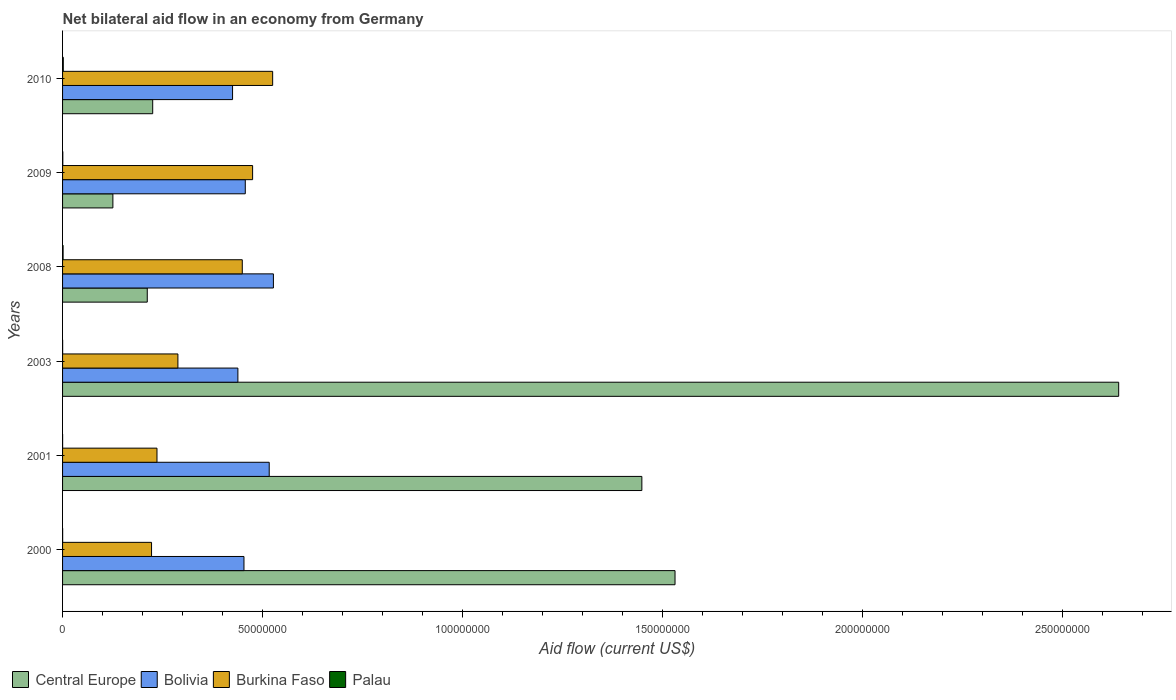Are the number of bars per tick equal to the number of legend labels?
Ensure brevity in your answer.  Yes. Are the number of bars on each tick of the Y-axis equal?
Ensure brevity in your answer.  Yes. How many bars are there on the 3rd tick from the top?
Keep it short and to the point. 4. How many bars are there on the 1st tick from the bottom?
Keep it short and to the point. 4. What is the label of the 4th group of bars from the top?
Your response must be concise. 2003. In how many cases, is the number of bars for a given year not equal to the number of legend labels?
Your answer should be compact. 0. What is the net bilateral aid flow in Bolivia in 2001?
Your answer should be very brief. 5.16e+07. Across all years, what is the minimum net bilateral aid flow in Central Europe?
Offer a terse response. 1.26e+07. In which year was the net bilateral aid flow in Bolivia maximum?
Give a very brief answer. 2008. In which year was the net bilateral aid flow in Burkina Faso minimum?
Your response must be concise. 2000. What is the total net bilateral aid flow in Burkina Faso in the graph?
Ensure brevity in your answer.  2.20e+08. What is the difference between the net bilateral aid flow in Bolivia in 2009 and the net bilateral aid flow in Central Europe in 2003?
Your answer should be very brief. -2.18e+08. What is the average net bilateral aid flow in Bolivia per year?
Ensure brevity in your answer.  4.69e+07. In the year 2003, what is the difference between the net bilateral aid flow in Bolivia and net bilateral aid flow in Palau?
Your answer should be compact. 4.38e+07. In how many years, is the net bilateral aid flow in Palau greater than 80000000 US$?
Keep it short and to the point. 0. What is the ratio of the net bilateral aid flow in Burkina Faso in 2000 to that in 2009?
Your response must be concise. 0.47. Is the difference between the net bilateral aid flow in Bolivia in 2001 and 2008 greater than the difference between the net bilateral aid flow in Palau in 2001 and 2008?
Provide a succinct answer. No. What is the difference between the highest and the second highest net bilateral aid flow in Central Europe?
Your answer should be very brief. 1.11e+08. In how many years, is the net bilateral aid flow in Burkina Faso greater than the average net bilateral aid flow in Burkina Faso taken over all years?
Make the answer very short. 3. Is it the case that in every year, the sum of the net bilateral aid flow in Burkina Faso and net bilateral aid flow in Palau is greater than the sum of net bilateral aid flow in Bolivia and net bilateral aid flow in Central Europe?
Keep it short and to the point. Yes. What does the 4th bar from the top in 2001 represents?
Make the answer very short. Central Europe. What does the 1st bar from the bottom in 2003 represents?
Keep it short and to the point. Central Europe. How many bars are there?
Your response must be concise. 24. How many years are there in the graph?
Ensure brevity in your answer.  6. Are the values on the major ticks of X-axis written in scientific E-notation?
Give a very brief answer. No. What is the title of the graph?
Keep it short and to the point. Net bilateral aid flow in an economy from Germany. What is the label or title of the Y-axis?
Ensure brevity in your answer.  Years. What is the Aid flow (current US$) in Central Europe in 2000?
Your response must be concise. 1.53e+08. What is the Aid flow (current US$) of Bolivia in 2000?
Keep it short and to the point. 4.53e+07. What is the Aid flow (current US$) in Burkina Faso in 2000?
Your response must be concise. 2.22e+07. What is the Aid flow (current US$) of Palau in 2000?
Provide a succinct answer. 2.00e+04. What is the Aid flow (current US$) of Central Europe in 2001?
Offer a terse response. 1.45e+08. What is the Aid flow (current US$) of Bolivia in 2001?
Make the answer very short. 5.16e+07. What is the Aid flow (current US$) of Burkina Faso in 2001?
Your answer should be very brief. 2.36e+07. What is the Aid flow (current US$) in Palau in 2001?
Give a very brief answer. 10000. What is the Aid flow (current US$) of Central Europe in 2003?
Give a very brief answer. 2.64e+08. What is the Aid flow (current US$) in Bolivia in 2003?
Make the answer very short. 4.38e+07. What is the Aid flow (current US$) of Burkina Faso in 2003?
Keep it short and to the point. 2.88e+07. What is the Aid flow (current US$) of Palau in 2003?
Your answer should be compact. 2.00e+04. What is the Aid flow (current US$) in Central Europe in 2008?
Your response must be concise. 2.12e+07. What is the Aid flow (current US$) in Bolivia in 2008?
Provide a succinct answer. 5.27e+07. What is the Aid flow (current US$) in Burkina Faso in 2008?
Make the answer very short. 4.49e+07. What is the Aid flow (current US$) in Central Europe in 2009?
Offer a very short reply. 1.26e+07. What is the Aid flow (current US$) in Bolivia in 2009?
Offer a terse response. 4.57e+07. What is the Aid flow (current US$) of Burkina Faso in 2009?
Give a very brief answer. 4.75e+07. What is the Aid flow (current US$) of Palau in 2009?
Ensure brevity in your answer.  6.00e+04. What is the Aid flow (current US$) in Central Europe in 2010?
Your answer should be compact. 2.25e+07. What is the Aid flow (current US$) in Bolivia in 2010?
Make the answer very short. 4.25e+07. What is the Aid flow (current US$) in Burkina Faso in 2010?
Make the answer very short. 5.25e+07. What is the Aid flow (current US$) of Palau in 2010?
Provide a succinct answer. 1.80e+05. Across all years, what is the maximum Aid flow (current US$) of Central Europe?
Provide a short and direct response. 2.64e+08. Across all years, what is the maximum Aid flow (current US$) of Bolivia?
Make the answer very short. 5.27e+07. Across all years, what is the maximum Aid flow (current US$) in Burkina Faso?
Offer a very short reply. 5.25e+07. Across all years, what is the minimum Aid flow (current US$) of Central Europe?
Your answer should be compact. 1.26e+07. Across all years, what is the minimum Aid flow (current US$) in Bolivia?
Offer a terse response. 4.25e+07. Across all years, what is the minimum Aid flow (current US$) in Burkina Faso?
Provide a short and direct response. 2.22e+07. What is the total Aid flow (current US$) in Central Europe in the graph?
Provide a succinct answer. 6.18e+08. What is the total Aid flow (current US$) in Bolivia in the graph?
Provide a short and direct response. 2.82e+08. What is the total Aid flow (current US$) of Burkina Faso in the graph?
Offer a very short reply. 2.20e+08. What is the total Aid flow (current US$) in Palau in the graph?
Your response must be concise. 4.20e+05. What is the difference between the Aid flow (current US$) in Central Europe in 2000 and that in 2001?
Your answer should be compact. 8.29e+06. What is the difference between the Aid flow (current US$) in Bolivia in 2000 and that in 2001?
Offer a terse response. -6.31e+06. What is the difference between the Aid flow (current US$) in Burkina Faso in 2000 and that in 2001?
Your answer should be very brief. -1.36e+06. What is the difference between the Aid flow (current US$) of Palau in 2000 and that in 2001?
Keep it short and to the point. 10000. What is the difference between the Aid flow (current US$) of Central Europe in 2000 and that in 2003?
Offer a very short reply. -1.11e+08. What is the difference between the Aid flow (current US$) of Bolivia in 2000 and that in 2003?
Provide a short and direct response. 1.52e+06. What is the difference between the Aid flow (current US$) in Burkina Faso in 2000 and that in 2003?
Your answer should be very brief. -6.59e+06. What is the difference between the Aid flow (current US$) in Central Europe in 2000 and that in 2008?
Offer a terse response. 1.32e+08. What is the difference between the Aid flow (current US$) of Bolivia in 2000 and that in 2008?
Your answer should be very brief. -7.36e+06. What is the difference between the Aid flow (current US$) of Burkina Faso in 2000 and that in 2008?
Your answer should be very brief. -2.27e+07. What is the difference between the Aid flow (current US$) of Palau in 2000 and that in 2008?
Offer a terse response. -1.10e+05. What is the difference between the Aid flow (current US$) in Central Europe in 2000 and that in 2009?
Offer a very short reply. 1.40e+08. What is the difference between the Aid flow (current US$) in Bolivia in 2000 and that in 2009?
Make the answer very short. -3.30e+05. What is the difference between the Aid flow (current US$) in Burkina Faso in 2000 and that in 2009?
Ensure brevity in your answer.  -2.53e+07. What is the difference between the Aid flow (current US$) in Central Europe in 2000 and that in 2010?
Make the answer very short. 1.31e+08. What is the difference between the Aid flow (current US$) in Bolivia in 2000 and that in 2010?
Ensure brevity in your answer.  2.85e+06. What is the difference between the Aid flow (current US$) of Burkina Faso in 2000 and that in 2010?
Provide a short and direct response. -3.03e+07. What is the difference between the Aid flow (current US$) of Central Europe in 2001 and that in 2003?
Keep it short and to the point. -1.19e+08. What is the difference between the Aid flow (current US$) in Bolivia in 2001 and that in 2003?
Your answer should be compact. 7.83e+06. What is the difference between the Aid flow (current US$) of Burkina Faso in 2001 and that in 2003?
Provide a short and direct response. -5.23e+06. What is the difference between the Aid flow (current US$) of Palau in 2001 and that in 2003?
Give a very brief answer. -10000. What is the difference between the Aid flow (current US$) in Central Europe in 2001 and that in 2008?
Your answer should be very brief. 1.24e+08. What is the difference between the Aid flow (current US$) in Bolivia in 2001 and that in 2008?
Make the answer very short. -1.05e+06. What is the difference between the Aid flow (current US$) in Burkina Faso in 2001 and that in 2008?
Make the answer very short. -2.13e+07. What is the difference between the Aid flow (current US$) of Palau in 2001 and that in 2008?
Your answer should be compact. -1.20e+05. What is the difference between the Aid flow (current US$) of Central Europe in 2001 and that in 2009?
Provide a short and direct response. 1.32e+08. What is the difference between the Aid flow (current US$) of Bolivia in 2001 and that in 2009?
Offer a terse response. 5.98e+06. What is the difference between the Aid flow (current US$) in Burkina Faso in 2001 and that in 2009?
Offer a terse response. -2.39e+07. What is the difference between the Aid flow (current US$) of Palau in 2001 and that in 2009?
Make the answer very short. -5.00e+04. What is the difference between the Aid flow (current US$) of Central Europe in 2001 and that in 2010?
Offer a very short reply. 1.22e+08. What is the difference between the Aid flow (current US$) of Bolivia in 2001 and that in 2010?
Give a very brief answer. 9.16e+06. What is the difference between the Aid flow (current US$) in Burkina Faso in 2001 and that in 2010?
Your answer should be very brief. -2.89e+07. What is the difference between the Aid flow (current US$) of Palau in 2001 and that in 2010?
Ensure brevity in your answer.  -1.70e+05. What is the difference between the Aid flow (current US$) of Central Europe in 2003 and that in 2008?
Make the answer very short. 2.43e+08. What is the difference between the Aid flow (current US$) of Bolivia in 2003 and that in 2008?
Keep it short and to the point. -8.88e+06. What is the difference between the Aid flow (current US$) in Burkina Faso in 2003 and that in 2008?
Offer a very short reply. -1.61e+07. What is the difference between the Aid flow (current US$) of Palau in 2003 and that in 2008?
Offer a terse response. -1.10e+05. What is the difference between the Aid flow (current US$) in Central Europe in 2003 and that in 2009?
Your answer should be compact. 2.51e+08. What is the difference between the Aid flow (current US$) of Bolivia in 2003 and that in 2009?
Your answer should be compact. -1.85e+06. What is the difference between the Aid flow (current US$) of Burkina Faso in 2003 and that in 2009?
Offer a terse response. -1.87e+07. What is the difference between the Aid flow (current US$) of Palau in 2003 and that in 2009?
Ensure brevity in your answer.  -4.00e+04. What is the difference between the Aid flow (current US$) of Central Europe in 2003 and that in 2010?
Your answer should be compact. 2.41e+08. What is the difference between the Aid flow (current US$) of Bolivia in 2003 and that in 2010?
Your response must be concise. 1.33e+06. What is the difference between the Aid flow (current US$) of Burkina Faso in 2003 and that in 2010?
Provide a short and direct response. -2.37e+07. What is the difference between the Aid flow (current US$) of Central Europe in 2008 and that in 2009?
Offer a very short reply. 8.59e+06. What is the difference between the Aid flow (current US$) of Bolivia in 2008 and that in 2009?
Provide a succinct answer. 7.03e+06. What is the difference between the Aid flow (current US$) of Burkina Faso in 2008 and that in 2009?
Provide a short and direct response. -2.58e+06. What is the difference between the Aid flow (current US$) in Central Europe in 2008 and that in 2010?
Keep it short and to the point. -1.36e+06. What is the difference between the Aid flow (current US$) of Bolivia in 2008 and that in 2010?
Your answer should be compact. 1.02e+07. What is the difference between the Aid flow (current US$) of Burkina Faso in 2008 and that in 2010?
Offer a very short reply. -7.59e+06. What is the difference between the Aid flow (current US$) of Central Europe in 2009 and that in 2010?
Make the answer very short. -9.95e+06. What is the difference between the Aid flow (current US$) of Bolivia in 2009 and that in 2010?
Offer a terse response. 3.18e+06. What is the difference between the Aid flow (current US$) in Burkina Faso in 2009 and that in 2010?
Ensure brevity in your answer.  -5.01e+06. What is the difference between the Aid flow (current US$) in Central Europe in 2000 and the Aid flow (current US$) in Bolivia in 2001?
Keep it short and to the point. 1.01e+08. What is the difference between the Aid flow (current US$) in Central Europe in 2000 and the Aid flow (current US$) in Burkina Faso in 2001?
Your answer should be very brief. 1.29e+08. What is the difference between the Aid flow (current US$) in Central Europe in 2000 and the Aid flow (current US$) in Palau in 2001?
Keep it short and to the point. 1.53e+08. What is the difference between the Aid flow (current US$) of Bolivia in 2000 and the Aid flow (current US$) of Burkina Faso in 2001?
Provide a short and direct response. 2.17e+07. What is the difference between the Aid flow (current US$) in Bolivia in 2000 and the Aid flow (current US$) in Palau in 2001?
Your answer should be very brief. 4.53e+07. What is the difference between the Aid flow (current US$) in Burkina Faso in 2000 and the Aid flow (current US$) in Palau in 2001?
Keep it short and to the point. 2.22e+07. What is the difference between the Aid flow (current US$) in Central Europe in 2000 and the Aid flow (current US$) in Bolivia in 2003?
Offer a very short reply. 1.09e+08. What is the difference between the Aid flow (current US$) in Central Europe in 2000 and the Aid flow (current US$) in Burkina Faso in 2003?
Your response must be concise. 1.24e+08. What is the difference between the Aid flow (current US$) in Central Europe in 2000 and the Aid flow (current US$) in Palau in 2003?
Keep it short and to the point. 1.53e+08. What is the difference between the Aid flow (current US$) of Bolivia in 2000 and the Aid flow (current US$) of Burkina Faso in 2003?
Your answer should be compact. 1.65e+07. What is the difference between the Aid flow (current US$) of Bolivia in 2000 and the Aid flow (current US$) of Palau in 2003?
Make the answer very short. 4.53e+07. What is the difference between the Aid flow (current US$) in Burkina Faso in 2000 and the Aid flow (current US$) in Palau in 2003?
Give a very brief answer. 2.22e+07. What is the difference between the Aid flow (current US$) in Central Europe in 2000 and the Aid flow (current US$) in Bolivia in 2008?
Give a very brief answer. 1.00e+08. What is the difference between the Aid flow (current US$) of Central Europe in 2000 and the Aid flow (current US$) of Burkina Faso in 2008?
Your answer should be very brief. 1.08e+08. What is the difference between the Aid flow (current US$) of Central Europe in 2000 and the Aid flow (current US$) of Palau in 2008?
Give a very brief answer. 1.53e+08. What is the difference between the Aid flow (current US$) of Bolivia in 2000 and the Aid flow (current US$) of Burkina Faso in 2008?
Offer a terse response. 4.20e+05. What is the difference between the Aid flow (current US$) of Bolivia in 2000 and the Aid flow (current US$) of Palau in 2008?
Provide a short and direct response. 4.52e+07. What is the difference between the Aid flow (current US$) in Burkina Faso in 2000 and the Aid flow (current US$) in Palau in 2008?
Provide a succinct answer. 2.21e+07. What is the difference between the Aid flow (current US$) in Central Europe in 2000 and the Aid flow (current US$) in Bolivia in 2009?
Make the answer very short. 1.07e+08. What is the difference between the Aid flow (current US$) in Central Europe in 2000 and the Aid flow (current US$) in Burkina Faso in 2009?
Give a very brief answer. 1.06e+08. What is the difference between the Aid flow (current US$) in Central Europe in 2000 and the Aid flow (current US$) in Palau in 2009?
Your answer should be compact. 1.53e+08. What is the difference between the Aid flow (current US$) of Bolivia in 2000 and the Aid flow (current US$) of Burkina Faso in 2009?
Keep it short and to the point. -2.16e+06. What is the difference between the Aid flow (current US$) of Bolivia in 2000 and the Aid flow (current US$) of Palau in 2009?
Make the answer very short. 4.53e+07. What is the difference between the Aid flow (current US$) in Burkina Faso in 2000 and the Aid flow (current US$) in Palau in 2009?
Ensure brevity in your answer.  2.22e+07. What is the difference between the Aid flow (current US$) in Central Europe in 2000 and the Aid flow (current US$) in Bolivia in 2010?
Offer a terse response. 1.11e+08. What is the difference between the Aid flow (current US$) of Central Europe in 2000 and the Aid flow (current US$) of Burkina Faso in 2010?
Provide a succinct answer. 1.01e+08. What is the difference between the Aid flow (current US$) in Central Europe in 2000 and the Aid flow (current US$) in Palau in 2010?
Your answer should be compact. 1.53e+08. What is the difference between the Aid flow (current US$) of Bolivia in 2000 and the Aid flow (current US$) of Burkina Faso in 2010?
Offer a very short reply. -7.17e+06. What is the difference between the Aid flow (current US$) of Bolivia in 2000 and the Aid flow (current US$) of Palau in 2010?
Offer a terse response. 4.52e+07. What is the difference between the Aid flow (current US$) of Burkina Faso in 2000 and the Aid flow (current US$) of Palau in 2010?
Your answer should be very brief. 2.21e+07. What is the difference between the Aid flow (current US$) of Central Europe in 2001 and the Aid flow (current US$) of Bolivia in 2003?
Give a very brief answer. 1.01e+08. What is the difference between the Aid flow (current US$) of Central Europe in 2001 and the Aid flow (current US$) of Burkina Faso in 2003?
Provide a succinct answer. 1.16e+08. What is the difference between the Aid flow (current US$) in Central Europe in 2001 and the Aid flow (current US$) in Palau in 2003?
Offer a terse response. 1.45e+08. What is the difference between the Aid flow (current US$) in Bolivia in 2001 and the Aid flow (current US$) in Burkina Faso in 2003?
Ensure brevity in your answer.  2.28e+07. What is the difference between the Aid flow (current US$) in Bolivia in 2001 and the Aid flow (current US$) in Palau in 2003?
Your answer should be very brief. 5.16e+07. What is the difference between the Aid flow (current US$) of Burkina Faso in 2001 and the Aid flow (current US$) of Palau in 2003?
Provide a short and direct response. 2.36e+07. What is the difference between the Aid flow (current US$) of Central Europe in 2001 and the Aid flow (current US$) of Bolivia in 2008?
Offer a very short reply. 9.21e+07. What is the difference between the Aid flow (current US$) of Central Europe in 2001 and the Aid flow (current US$) of Burkina Faso in 2008?
Your answer should be very brief. 9.99e+07. What is the difference between the Aid flow (current US$) of Central Europe in 2001 and the Aid flow (current US$) of Palau in 2008?
Offer a very short reply. 1.45e+08. What is the difference between the Aid flow (current US$) in Bolivia in 2001 and the Aid flow (current US$) in Burkina Faso in 2008?
Keep it short and to the point. 6.73e+06. What is the difference between the Aid flow (current US$) of Bolivia in 2001 and the Aid flow (current US$) of Palau in 2008?
Keep it short and to the point. 5.15e+07. What is the difference between the Aid flow (current US$) in Burkina Faso in 2001 and the Aid flow (current US$) in Palau in 2008?
Make the answer very short. 2.35e+07. What is the difference between the Aid flow (current US$) in Central Europe in 2001 and the Aid flow (current US$) in Bolivia in 2009?
Offer a terse response. 9.91e+07. What is the difference between the Aid flow (current US$) in Central Europe in 2001 and the Aid flow (current US$) in Burkina Faso in 2009?
Your answer should be very brief. 9.73e+07. What is the difference between the Aid flow (current US$) of Central Europe in 2001 and the Aid flow (current US$) of Palau in 2009?
Offer a very short reply. 1.45e+08. What is the difference between the Aid flow (current US$) in Bolivia in 2001 and the Aid flow (current US$) in Burkina Faso in 2009?
Keep it short and to the point. 4.15e+06. What is the difference between the Aid flow (current US$) in Bolivia in 2001 and the Aid flow (current US$) in Palau in 2009?
Ensure brevity in your answer.  5.16e+07. What is the difference between the Aid flow (current US$) of Burkina Faso in 2001 and the Aid flow (current US$) of Palau in 2009?
Your response must be concise. 2.35e+07. What is the difference between the Aid flow (current US$) of Central Europe in 2001 and the Aid flow (current US$) of Bolivia in 2010?
Your answer should be very brief. 1.02e+08. What is the difference between the Aid flow (current US$) in Central Europe in 2001 and the Aid flow (current US$) in Burkina Faso in 2010?
Your answer should be very brief. 9.23e+07. What is the difference between the Aid flow (current US$) in Central Europe in 2001 and the Aid flow (current US$) in Palau in 2010?
Ensure brevity in your answer.  1.45e+08. What is the difference between the Aid flow (current US$) in Bolivia in 2001 and the Aid flow (current US$) in Burkina Faso in 2010?
Your response must be concise. -8.60e+05. What is the difference between the Aid flow (current US$) in Bolivia in 2001 and the Aid flow (current US$) in Palau in 2010?
Give a very brief answer. 5.15e+07. What is the difference between the Aid flow (current US$) in Burkina Faso in 2001 and the Aid flow (current US$) in Palau in 2010?
Your response must be concise. 2.34e+07. What is the difference between the Aid flow (current US$) in Central Europe in 2003 and the Aid flow (current US$) in Bolivia in 2008?
Make the answer very short. 2.11e+08. What is the difference between the Aid flow (current US$) of Central Europe in 2003 and the Aid flow (current US$) of Burkina Faso in 2008?
Provide a short and direct response. 2.19e+08. What is the difference between the Aid flow (current US$) in Central Europe in 2003 and the Aid flow (current US$) in Palau in 2008?
Provide a short and direct response. 2.64e+08. What is the difference between the Aid flow (current US$) of Bolivia in 2003 and the Aid flow (current US$) of Burkina Faso in 2008?
Your answer should be very brief. -1.10e+06. What is the difference between the Aid flow (current US$) of Bolivia in 2003 and the Aid flow (current US$) of Palau in 2008?
Your response must be concise. 4.37e+07. What is the difference between the Aid flow (current US$) in Burkina Faso in 2003 and the Aid flow (current US$) in Palau in 2008?
Ensure brevity in your answer.  2.87e+07. What is the difference between the Aid flow (current US$) in Central Europe in 2003 and the Aid flow (current US$) in Bolivia in 2009?
Your answer should be very brief. 2.18e+08. What is the difference between the Aid flow (current US$) of Central Europe in 2003 and the Aid flow (current US$) of Burkina Faso in 2009?
Keep it short and to the point. 2.16e+08. What is the difference between the Aid flow (current US$) in Central Europe in 2003 and the Aid flow (current US$) in Palau in 2009?
Your answer should be compact. 2.64e+08. What is the difference between the Aid flow (current US$) in Bolivia in 2003 and the Aid flow (current US$) in Burkina Faso in 2009?
Your response must be concise. -3.68e+06. What is the difference between the Aid flow (current US$) in Bolivia in 2003 and the Aid flow (current US$) in Palau in 2009?
Your response must be concise. 4.38e+07. What is the difference between the Aid flow (current US$) of Burkina Faso in 2003 and the Aid flow (current US$) of Palau in 2009?
Your answer should be compact. 2.88e+07. What is the difference between the Aid flow (current US$) in Central Europe in 2003 and the Aid flow (current US$) in Bolivia in 2010?
Ensure brevity in your answer.  2.21e+08. What is the difference between the Aid flow (current US$) of Central Europe in 2003 and the Aid flow (current US$) of Burkina Faso in 2010?
Your answer should be very brief. 2.11e+08. What is the difference between the Aid flow (current US$) of Central Europe in 2003 and the Aid flow (current US$) of Palau in 2010?
Your answer should be very brief. 2.64e+08. What is the difference between the Aid flow (current US$) in Bolivia in 2003 and the Aid flow (current US$) in Burkina Faso in 2010?
Provide a short and direct response. -8.69e+06. What is the difference between the Aid flow (current US$) of Bolivia in 2003 and the Aid flow (current US$) of Palau in 2010?
Provide a short and direct response. 4.36e+07. What is the difference between the Aid flow (current US$) in Burkina Faso in 2003 and the Aid flow (current US$) in Palau in 2010?
Keep it short and to the point. 2.86e+07. What is the difference between the Aid flow (current US$) in Central Europe in 2008 and the Aid flow (current US$) in Bolivia in 2009?
Your answer should be very brief. -2.45e+07. What is the difference between the Aid flow (current US$) in Central Europe in 2008 and the Aid flow (current US$) in Burkina Faso in 2009?
Offer a very short reply. -2.63e+07. What is the difference between the Aid flow (current US$) in Central Europe in 2008 and the Aid flow (current US$) in Palau in 2009?
Offer a terse response. 2.11e+07. What is the difference between the Aid flow (current US$) in Bolivia in 2008 and the Aid flow (current US$) in Burkina Faso in 2009?
Your answer should be very brief. 5.20e+06. What is the difference between the Aid flow (current US$) in Bolivia in 2008 and the Aid flow (current US$) in Palau in 2009?
Your answer should be very brief. 5.26e+07. What is the difference between the Aid flow (current US$) of Burkina Faso in 2008 and the Aid flow (current US$) of Palau in 2009?
Provide a succinct answer. 4.49e+07. What is the difference between the Aid flow (current US$) of Central Europe in 2008 and the Aid flow (current US$) of Bolivia in 2010?
Your response must be concise. -2.13e+07. What is the difference between the Aid flow (current US$) in Central Europe in 2008 and the Aid flow (current US$) in Burkina Faso in 2010?
Provide a short and direct response. -3.13e+07. What is the difference between the Aid flow (current US$) in Central Europe in 2008 and the Aid flow (current US$) in Palau in 2010?
Offer a terse response. 2.10e+07. What is the difference between the Aid flow (current US$) in Bolivia in 2008 and the Aid flow (current US$) in Palau in 2010?
Provide a short and direct response. 5.25e+07. What is the difference between the Aid flow (current US$) in Burkina Faso in 2008 and the Aid flow (current US$) in Palau in 2010?
Ensure brevity in your answer.  4.47e+07. What is the difference between the Aid flow (current US$) in Central Europe in 2009 and the Aid flow (current US$) in Bolivia in 2010?
Ensure brevity in your answer.  -2.99e+07. What is the difference between the Aid flow (current US$) in Central Europe in 2009 and the Aid flow (current US$) in Burkina Faso in 2010?
Your response must be concise. -3.99e+07. What is the difference between the Aid flow (current US$) of Central Europe in 2009 and the Aid flow (current US$) of Palau in 2010?
Your answer should be compact. 1.24e+07. What is the difference between the Aid flow (current US$) of Bolivia in 2009 and the Aid flow (current US$) of Burkina Faso in 2010?
Ensure brevity in your answer.  -6.84e+06. What is the difference between the Aid flow (current US$) of Bolivia in 2009 and the Aid flow (current US$) of Palau in 2010?
Provide a succinct answer. 4.55e+07. What is the difference between the Aid flow (current US$) of Burkina Faso in 2009 and the Aid flow (current US$) of Palau in 2010?
Your answer should be compact. 4.73e+07. What is the average Aid flow (current US$) in Central Europe per year?
Offer a very short reply. 1.03e+08. What is the average Aid flow (current US$) in Bolivia per year?
Your answer should be compact. 4.69e+07. What is the average Aid flow (current US$) in Burkina Faso per year?
Offer a very short reply. 3.66e+07. In the year 2000, what is the difference between the Aid flow (current US$) of Central Europe and Aid flow (current US$) of Bolivia?
Offer a terse response. 1.08e+08. In the year 2000, what is the difference between the Aid flow (current US$) of Central Europe and Aid flow (current US$) of Burkina Faso?
Provide a succinct answer. 1.31e+08. In the year 2000, what is the difference between the Aid flow (current US$) in Central Europe and Aid flow (current US$) in Palau?
Your answer should be compact. 1.53e+08. In the year 2000, what is the difference between the Aid flow (current US$) in Bolivia and Aid flow (current US$) in Burkina Faso?
Ensure brevity in your answer.  2.31e+07. In the year 2000, what is the difference between the Aid flow (current US$) of Bolivia and Aid flow (current US$) of Palau?
Provide a short and direct response. 4.53e+07. In the year 2000, what is the difference between the Aid flow (current US$) of Burkina Faso and Aid flow (current US$) of Palau?
Your answer should be very brief. 2.22e+07. In the year 2001, what is the difference between the Aid flow (current US$) in Central Europe and Aid flow (current US$) in Bolivia?
Provide a short and direct response. 9.31e+07. In the year 2001, what is the difference between the Aid flow (current US$) in Central Europe and Aid flow (current US$) in Burkina Faso?
Offer a terse response. 1.21e+08. In the year 2001, what is the difference between the Aid flow (current US$) of Central Europe and Aid flow (current US$) of Palau?
Offer a very short reply. 1.45e+08. In the year 2001, what is the difference between the Aid flow (current US$) of Bolivia and Aid flow (current US$) of Burkina Faso?
Provide a short and direct response. 2.80e+07. In the year 2001, what is the difference between the Aid flow (current US$) in Bolivia and Aid flow (current US$) in Palau?
Offer a terse response. 5.16e+07. In the year 2001, what is the difference between the Aid flow (current US$) in Burkina Faso and Aid flow (current US$) in Palau?
Offer a very short reply. 2.36e+07. In the year 2003, what is the difference between the Aid flow (current US$) in Central Europe and Aid flow (current US$) in Bolivia?
Your answer should be compact. 2.20e+08. In the year 2003, what is the difference between the Aid flow (current US$) in Central Europe and Aid flow (current US$) in Burkina Faso?
Offer a very short reply. 2.35e+08. In the year 2003, what is the difference between the Aid flow (current US$) of Central Europe and Aid flow (current US$) of Palau?
Make the answer very short. 2.64e+08. In the year 2003, what is the difference between the Aid flow (current US$) in Bolivia and Aid flow (current US$) in Burkina Faso?
Your response must be concise. 1.50e+07. In the year 2003, what is the difference between the Aid flow (current US$) in Bolivia and Aid flow (current US$) in Palau?
Ensure brevity in your answer.  4.38e+07. In the year 2003, what is the difference between the Aid flow (current US$) of Burkina Faso and Aid flow (current US$) of Palau?
Provide a short and direct response. 2.88e+07. In the year 2008, what is the difference between the Aid flow (current US$) of Central Europe and Aid flow (current US$) of Bolivia?
Make the answer very short. -3.15e+07. In the year 2008, what is the difference between the Aid flow (current US$) in Central Europe and Aid flow (current US$) in Burkina Faso?
Offer a terse response. -2.38e+07. In the year 2008, what is the difference between the Aid flow (current US$) of Central Europe and Aid flow (current US$) of Palau?
Your response must be concise. 2.10e+07. In the year 2008, what is the difference between the Aid flow (current US$) of Bolivia and Aid flow (current US$) of Burkina Faso?
Make the answer very short. 7.78e+06. In the year 2008, what is the difference between the Aid flow (current US$) in Bolivia and Aid flow (current US$) in Palau?
Provide a short and direct response. 5.26e+07. In the year 2008, what is the difference between the Aid flow (current US$) of Burkina Faso and Aid flow (current US$) of Palau?
Your answer should be very brief. 4.48e+07. In the year 2009, what is the difference between the Aid flow (current US$) of Central Europe and Aid flow (current US$) of Bolivia?
Your answer should be compact. -3.31e+07. In the year 2009, what is the difference between the Aid flow (current US$) in Central Europe and Aid flow (current US$) in Burkina Faso?
Make the answer very short. -3.49e+07. In the year 2009, what is the difference between the Aid flow (current US$) in Central Europe and Aid flow (current US$) in Palau?
Your answer should be compact. 1.25e+07. In the year 2009, what is the difference between the Aid flow (current US$) in Bolivia and Aid flow (current US$) in Burkina Faso?
Your response must be concise. -1.83e+06. In the year 2009, what is the difference between the Aid flow (current US$) in Bolivia and Aid flow (current US$) in Palau?
Make the answer very short. 4.56e+07. In the year 2009, what is the difference between the Aid flow (current US$) of Burkina Faso and Aid flow (current US$) of Palau?
Provide a succinct answer. 4.74e+07. In the year 2010, what is the difference between the Aid flow (current US$) in Central Europe and Aid flow (current US$) in Bolivia?
Keep it short and to the point. -2.00e+07. In the year 2010, what is the difference between the Aid flow (current US$) in Central Europe and Aid flow (current US$) in Burkina Faso?
Offer a terse response. -3.00e+07. In the year 2010, what is the difference between the Aid flow (current US$) in Central Europe and Aid flow (current US$) in Palau?
Provide a succinct answer. 2.24e+07. In the year 2010, what is the difference between the Aid flow (current US$) of Bolivia and Aid flow (current US$) of Burkina Faso?
Offer a terse response. -1.00e+07. In the year 2010, what is the difference between the Aid flow (current US$) in Bolivia and Aid flow (current US$) in Palau?
Your answer should be very brief. 4.23e+07. In the year 2010, what is the difference between the Aid flow (current US$) of Burkina Faso and Aid flow (current US$) of Palau?
Offer a very short reply. 5.23e+07. What is the ratio of the Aid flow (current US$) in Central Europe in 2000 to that in 2001?
Ensure brevity in your answer.  1.06. What is the ratio of the Aid flow (current US$) of Bolivia in 2000 to that in 2001?
Provide a succinct answer. 0.88. What is the ratio of the Aid flow (current US$) of Burkina Faso in 2000 to that in 2001?
Make the answer very short. 0.94. What is the ratio of the Aid flow (current US$) in Central Europe in 2000 to that in 2003?
Provide a short and direct response. 0.58. What is the ratio of the Aid flow (current US$) of Bolivia in 2000 to that in 2003?
Provide a short and direct response. 1.03. What is the ratio of the Aid flow (current US$) in Burkina Faso in 2000 to that in 2003?
Your answer should be very brief. 0.77. What is the ratio of the Aid flow (current US$) in Palau in 2000 to that in 2003?
Your answer should be compact. 1. What is the ratio of the Aid flow (current US$) of Central Europe in 2000 to that in 2008?
Provide a succinct answer. 7.23. What is the ratio of the Aid flow (current US$) of Bolivia in 2000 to that in 2008?
Give a very brief answer. 0.86. What is the ratio of the Aid flow (current US$) of Burkina Faso in 2000 to that in 2008?
Your response must be concise. 0.5. What is the ratio of the Aid flow (current US$) of Palau in 2000 to that in 2008?
Provide a short and direct response. 0.15. What is the ratio of the Aid flow (current US$) in Central Europe in 2000 to that in 2009?
Give a very brief answer. 12.17. What is the ratio of the Aid flow (current US$) in Bolivia in 2000 to that in 2009?
Your answer should be compact. 0.99. What is the ratio of the Aid flow (current US$) in Burkina Faso in 2000 to that in 2009?
Give a very brief answer. 0.47. What is the ratio of the Aid flow (current US$) of Palau in 2000 to that in 2009?
Provide a short and direct response. 0.33. What is the ratio of the Aid flow (current US$) of Central Europe in 2000 to that in 2010?
Ensure brevity in your answer.  6.79. What is the ratio of the Aid flow (current US$) of Bolivia in 2000 to that in 2010?
Give a very brief answer. 1.07. What is the ratio of the Aid flow (current US$) of Burkina Faso in 2000 to that in 2010?
Give a very brief answer. 0.42. What is the ratio of the Aid flow (current US$) in Central Europe in 2001 to that in 2003?
Provide a short and direct response. 0.55. What is the ratio of the Aid flow (current US$) in Bolivia in 2001 to that in 2003?
Provide a succinct answer. 1.18. What is the ratio of the Aid flow (current US$) in Burkina Faso in 2001 to that in 2003?
Provide a short and direct response. 0.82. What is the ratio of the Aid flow (current US$) in Central Europe in 2001 to that in 2008?
Keep it short and to the point. 6.84. What is the ratio of the Aid flow (current US$) of Bolivia in 2001 to that in 2008?
Make the answer very short. 0.98. What is the ratio of the Aid flow (current US$) in Burkina Faso in 2001 to that in 2008?
Keep it short and to the point. 0.53. What is the ratio of the Aid flow (current US$) of Palau in 2001 to that in 2008?
Give a very brief answer. 0.08. What is the ratio of the Aid flow (current US$) in Central Europe in 2001 to that in 2009?
Offer a terse response. 11.51. What is the ratio of the Aid flow (current US$) of Bolivia in 2001 to that in 2009?
Offer a very short reply. 1.13. What is the ratio of the Aid flow (current US$) in Burkina Faso in 2001 to that in 2009?
Offer a terse response. 0.5. What is the ratio of the Aid flow (current US$) in Palau in 2001 to that in 2009?
Keep it short and to the point. 0.17. What is the ratio of the Aid flow (current US$) in Central Europe in 2001 to that in 2010?
Provide a succinct answer. 6.43. What is the ratio of the Aid flow (current US$) of Bolivia in 2001 to that in 2010?
Provide a succinct answer. 1.22. What is the ratio of the Aid flow (current US$) in Burkina Faso in 2001 to that in 2010?
Your answer should be very brief. 0.45. What is the ratio of the Aid flow (current US$) in Palau in 2001 to that in 2010?
Your answer should be compact. 0.06. What is the ratio of the Aid flow (current US$) in Central Europe in 2003 to that in 2008?
Make the answer very short. 12.47. What is the ratio of the Aid flow (current US$) of Bolivia in 2003 to that in 2008?
Offer a terse response. 0.83. What is the ratio of the Aid flow (current US$) in Burkina Faso in 2003 to that in 2008?
Provide a short and direct response. 0.64. What is the ratio of the Aid flow (current US$) of Palau in 2003 to that in 2008?
Provide a short and direct response. 0.15. What is the ratio of the Aid flow (current US$) in Central Europe in 2003 to that in 2009?
Make the answer very short. 20.98. What is the ratio of the Aid flow (current US$) in Bolivia in 2003 to that in 2009?
Provide a succinct answer. 0.96. What is the ratio of the Aid flow (current US$) in Burkina Faso in 2003 to that in 2009?
Provide a short and direct response. 0.61. What is the ratio of the Aid flow (current US$) of Central Europe in 2003 to that in 2010?
Your response must be concise. 11.72. What is the ratio of the Aid flow (current US$) of Bolivia in 2003 to that in 2010?
Offer a terse response. 1.03. What is the ratio of the Aid flow (current US$) in Burkina Faso in 2003 to that in 2010?
Provide a short and direct response. 0.55. What is the ratio of the Aid flow (current US$) of Palau in 2003 to that in 2010?
Provide a succinct answer. 0.11. What is the ratio of the Aid flow (current US$) in Central Europe in 2008 to that in 2009?
Offer a very short reply. 1.68. What is the ratio of the Aid flow (current US$) of Bolivia in 2008 to that in 2009?
Offer a very short reply. 1.15. What is the ratio of the Aid flow (current US$) in Burkina Faso in 2008 to that in 2009?
Provide a short and direct response. 0.95. What is the ratio of the Aid flow (current US$) in Palau in 2008 to that in 2009?
Offer a terse response. 2.17. What is the ratio of the Aid flow (current US$) in Central Europe in 2008 to that in 2010?
Give a very brief answer. 0.94. What is the ratio of the Aid flow (current US$) in Bolivia in 2008 to that in 2010?
Make the answer very short. 1.24. What is the ratio of the Aid flow (current US$) of Burkina Faso in 2008 to that in 2010?
Offer a terse response. 0.86. What is the ratio of the Aid flow (current US$) in Palau in 2008 to that in 2010?
Keep it short and to the point. 0.72. What is the ratio of the Aid flow (current US$) in Central Europe in 2009 to that in 2010?
Provide a succinct answer. 0.56. What is the ratio of the Aid flow (current US$) of Bolivia in 2009 to that in 2010?
Make the answer very short. 1.07. What is the ratio of the Aid flow (current US$) in Burkina Faso in 2009 to that in 2010?
Provide a short and direct response. 0.9. What is the ratio of the Aid flow (current US$) of Palau in 2009 to that in 2010?
Provide a succinct answer. 0.33. What is the difference between the highest and the second highest Aid flow (current US$) of Central Europe?
Provide a short and direct response. 1.11e+08. What is the difference between the highest and the second highest Aid flow (current US$) in Bolivia?
Keep it short and to the point. 1.05e+06. What is the difference between the highest and the second highest Aid flow (current US$) in Burkina Faso?
Keep it short and to the point. 5.01e+06. What is the difference between the highest and the second highest Aid flow (current US$) of Palau?
Your answer should be very brief. 5.00e+04. What is the difference between the highest and the lowest Aid flow (current US$) of Central Europe?
Ensure brevity in your answer.  2.51e+08. What is the difference between the highest and the lowest Aid flow (current US$) of Bolivia?
Provide a succinct answer. 1.02e+07. What is the difference between the highest and the lowest Aid flow (current US$) of Burkina Faso?
Provide a succinct answer. 3.03e+07. What is the difference between the highest and the lowest Aid flow (current US$) in Palau?
Offer a very short reply. 1.70e+05. 